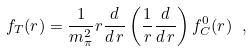Convert formula to latex. <formula><loc_0><loc_0><loc_500><loc_500>f _ { T } ( r ) = \frac { 1 } { m _ { \pi } ^ { 2 } } r \frac { d } { d \, r } \left ( \frac { 1 } { r } \frac { d } { d \, r } \right ) f ^ { 0 } _ { C } ( r ) \ ,</formula> 